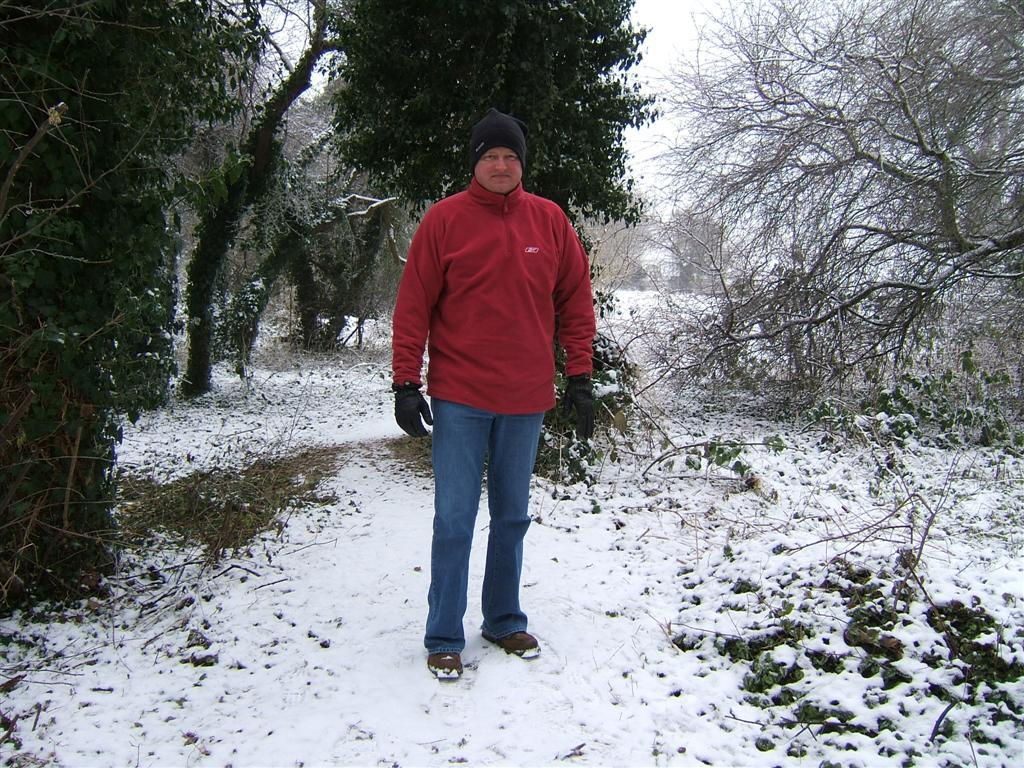What is the main subject of the image? There is a person standing in the image. What colors can be seen on the person's clothing? The person is wearing red and blue colors. What type of headwear is the person wearing? The person is wearing a black cap. What can be seen in the background of the image? There are trees and snow visible in the background of the image. How many parcels can be seen in the image? There are no parcels present in the image. What type of fan is visible in the image? There is no fan present in the image. 